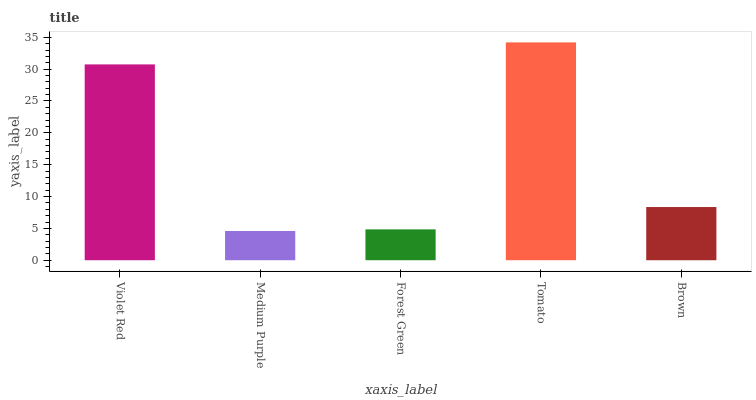Is Medium Purple the minimum?
Answer yes or no. Yes. Is Tomato the maximum?
Answer yes or no. Yes. Is Forest Green the minimum?
Answer yes or no. No. Is Forest Green the maximum?
Answer yes or no. No. Is Forest Green greater than Medium Purple?
Answer yes or no. Yes. Is Medium Purple less than Forest Green?
Answer yes or no. Yes. Is Medium Purple greater than Forest Green?
Answer yes or no. No. Is Forest Green less than Medium Purple?
Answer yes or no. No. Is Brown the high median?
Answer yes or no. Yes. Is Brown the low median?
Answer yes or no. Yes. Is Tomato the high median?
Answer yes or no. No. Is Forest Green the low median?
Answer yes or no. No. 